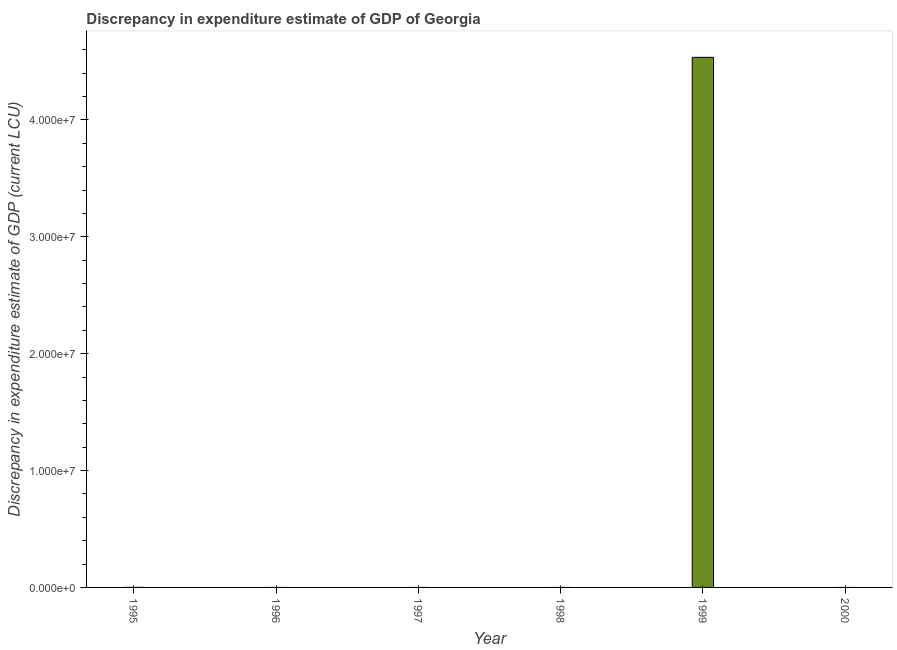Does the graph contain grids?
Ensure brevity in your answer.  No. What is the title of the graph?
Your answer should be compact. Discrepancy in expenditure estimate of GDP of Georgia. What is the label or title of the Y-axis?
Your answer should be compact. Discrepancy in expenditure estimate of GDP (current LCU). What is the discrepancy in expenditure estimate of gdp in 2000?
Provide a short and direct response. 0. Across all years, what is the maximum discrepancy in expenditure estimate of gdp?
Provide a succinct answer. 4.54e+07. What is the sum of the discrepancy in expenditure estimate of gdp?
Your answer should be very brief. 4.54e+07. What is the average discrepancy in expenditure estimate of gdp per year?
Offer a terse response. 7.56e+06. What is the median discrepancy in expenditure estimate of gdp?
Ensure brevity in your answer.  0. Is the discrepancy in expenditure estimate of gdp in 1995 less than that in 1999?
Your answer should be very brief. Yes. Is the sum of the discrepancy in expenditure estimate of gdp in 1995 and 1999 greater than the maximum discrepancy in expenditure estimate of gdp across all years?
Provide a succinct answer. Yes. What is the difference between the highest and the lowest discrepancy in expenditure estimate of gdp?
Your answer should be very brief. 4.54e+07. In how many years, is the discrepancy in expenditure estimate of gdp greater than the average discrepancy in expenditure estimate of gdp taken over all years?
Your response must be concise. 1. How many bars are there?
Provide a succinct answer. 2. How many years are there in the graph?
Your answer should be very brief. 6. What is the difference between two consecutive major ticks on the Y-axis?
Provide a short and direct response. 1.00e+07. Are the values on the major ticks of Y-axis written in scientific E-notation?
Your answer should be compact. Yes. What is the Discrepancy in expenditure estimate of GDP (current LCU) of 1999?
Provide a short and direct response. 4.54e+07. What is the Discrepancy in expenditure estimate of GDP (current LCU) of 2000?
Make the answer very short. 0. What is the difference between the Discrepancy in expenditure estimate of GDP (current LCU) in 1995 and 1999?
Your answer should be compact. -4.54e+07. 